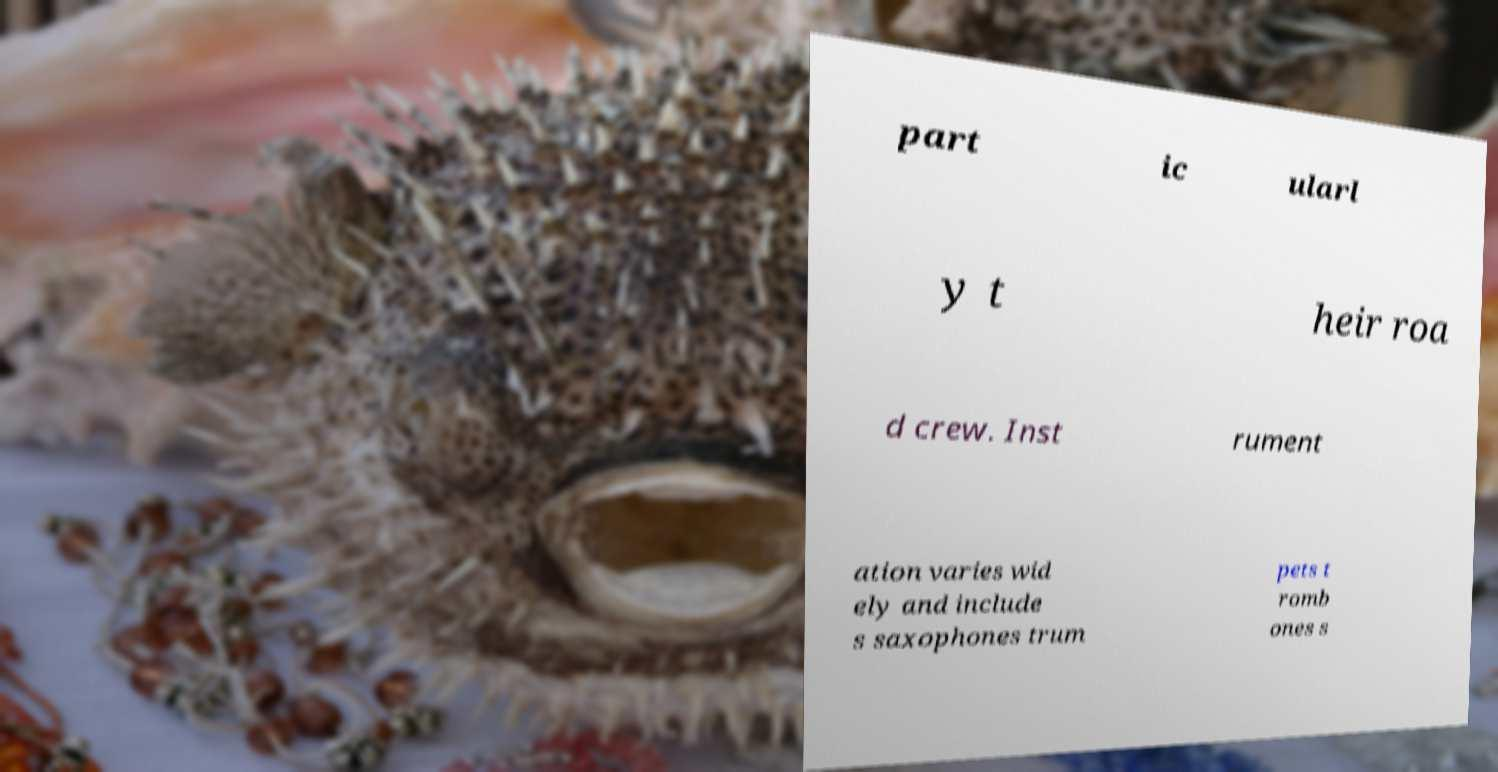Can you accurately transcribe the text from the provided image for me? part ic ularl y t heir roa d crew. Inst rument ation varies wid ely and include s saxophones trum pets t romb ones s 